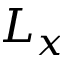Convert formula to latex. <formula><loc_0><loc_0><loc_500><loc_500>L _ { x }</formula> 